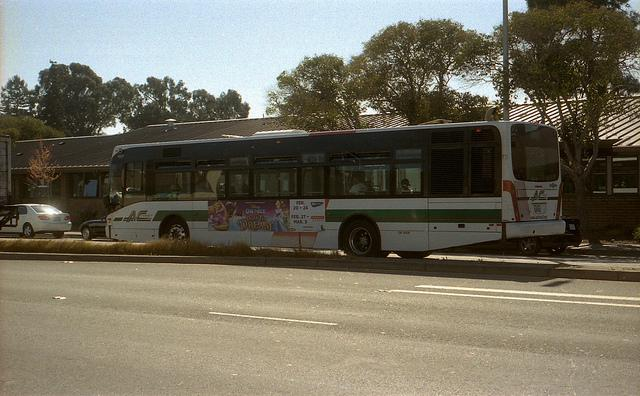What is the bus driving in? road 